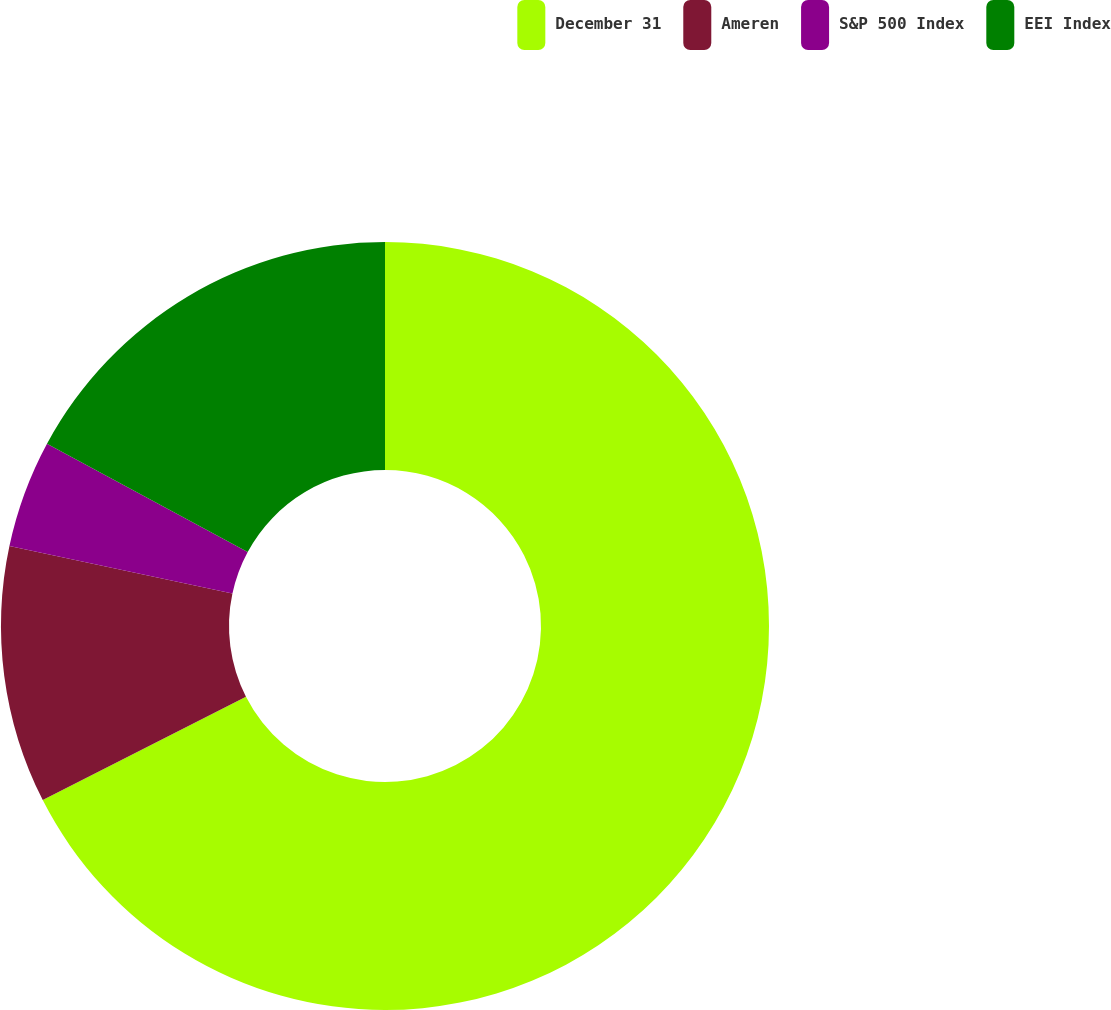Convert chart to OTSL. <chart><loc_0><loc_0><loc_500><loc_500><pie_chart><fcel>December 31<fcel>Ameren<fcel>S&P 500 Index<fcel>EEI Index<nl><fcel>67.51%<fcel>10.83%<fcel>4.53%<fcel>17.13%<nl></chart> 